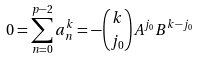Convert formula to latex. <formula><loc_0><loc_0><loc_500><loc_500>0 = \sum _ { n = 0 } ^ { p - 2 } a _ { n } ^ { k } = - \binom { k } { j _ { 0 } } A ^ { j _ { 0 } } B ^ { k - j _ { 0 } }</formula> 